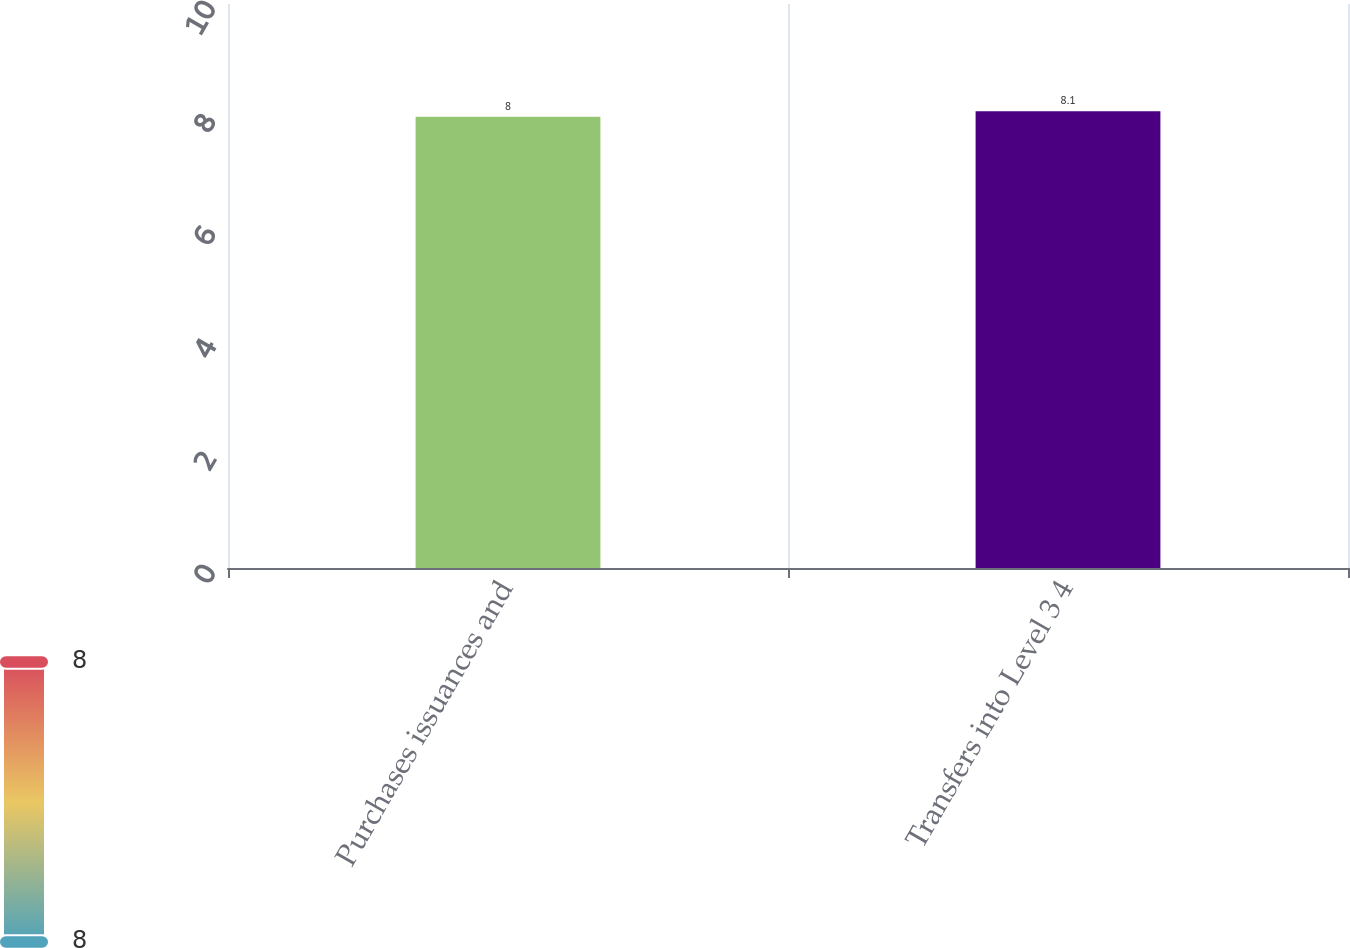Convert chart to OTSL. <chart><loc_0><loc_0><loc_500><loc_500><bar_chart><fcel>Purchases issuances and<fcel>Transfers into Level 3 4<nl><fcel>8<fcel>8.1<nl></chart> 